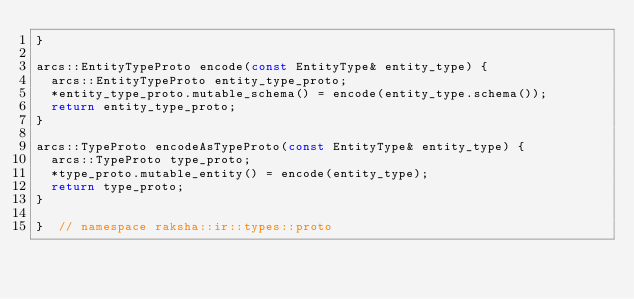Convert code to text. <code><loc_0><loc_0><loc_500><loc_500><_C++_>}

arcs::EntityTypeProto encode(const EntityType& entity_type) {
  arcs::EntityTypeProto entity_type_proto;
  *entity_type_proto.mutable_schema() = encode(entity_type.schema());
  return entity_type_proto;
}

arcs::TypeProto encodeAsTypeProto(const EntityType& entity_type) {
  arcs::TypeProto type_proto;
  *type_proto.mutable_entity() = encode(entity_type);
  return type_proto;
}

}  // namespace raksha::ir::types::proto
</code> 